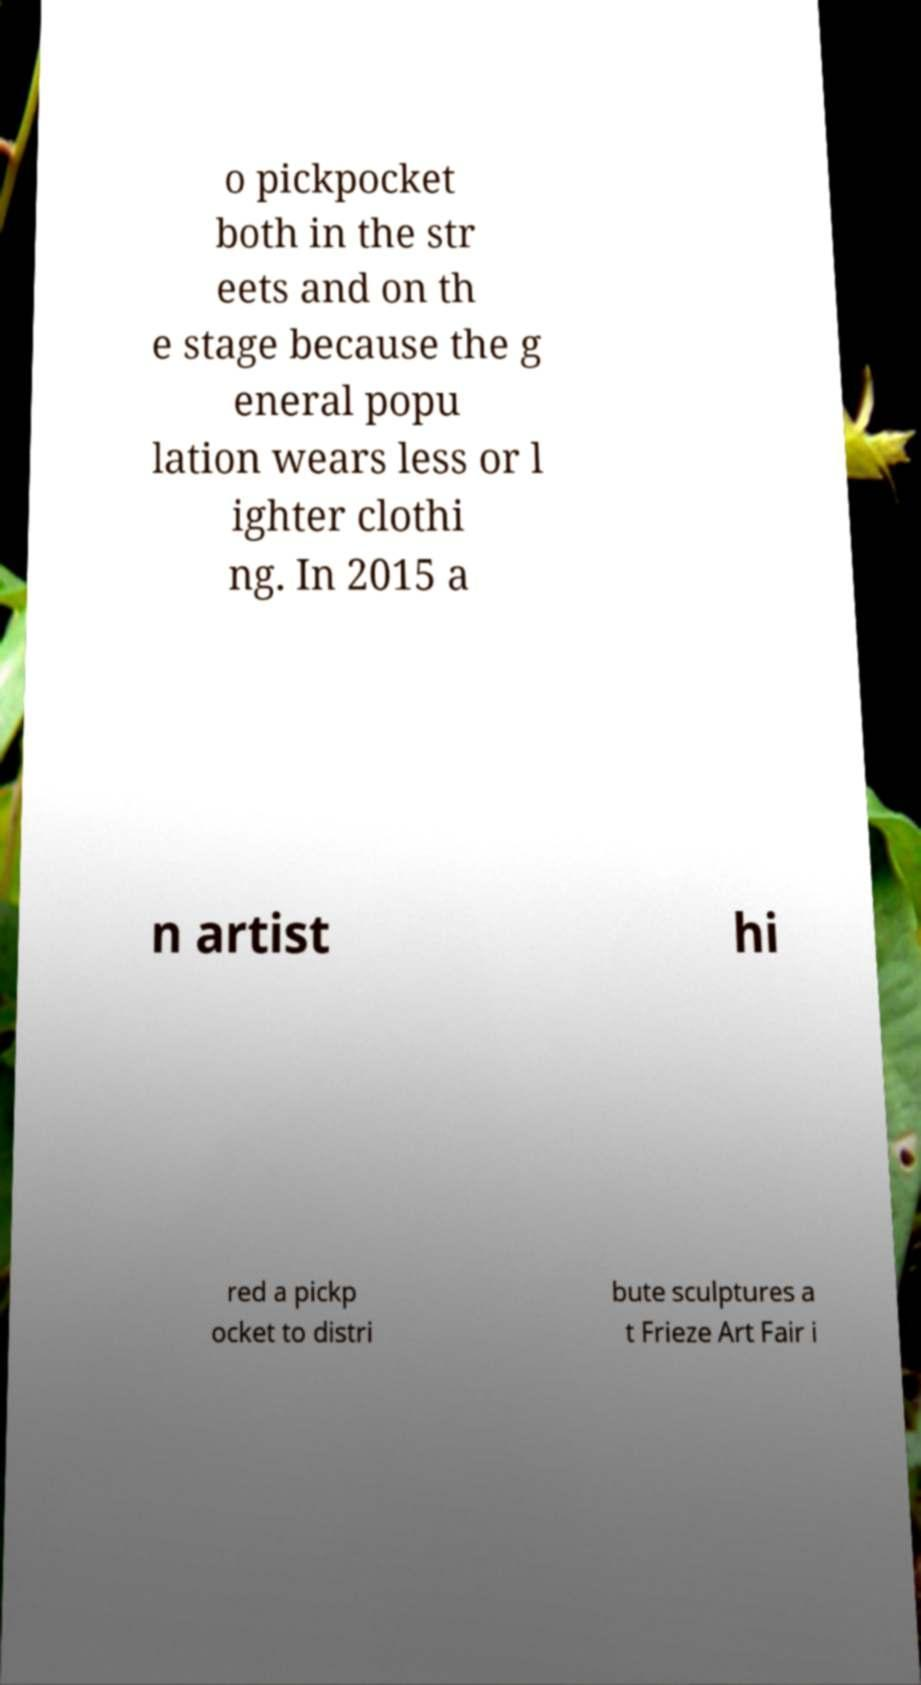I need the written content from this picture converted into text. Can you do that? o pickpocket both in the str eets and on th e stage because the g eneral popu lation wears less or l ighter clothi ng. In 2015 a n artist hi red a pickp ocket to distri bute sculptures a t Frieze Art Fair i 